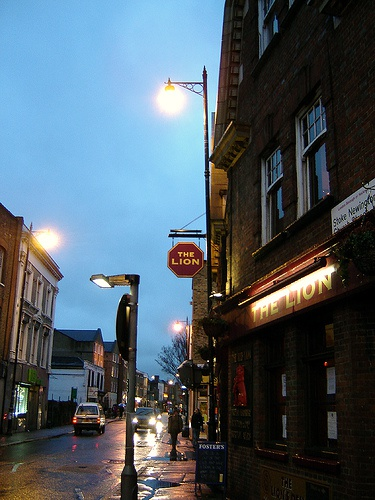Describe the objects in this image and their specific colors. I can see car in lightblue, black, gray, darkgray, and maroon tones, car in lightblue, gray, white, black, and blue tones, people in lightblue, black, maroon, and gray tones, people in lightblue, black, maroon, and gray tones, and car in lightblue, gray, white, darkgray, and olive tones in this image. 